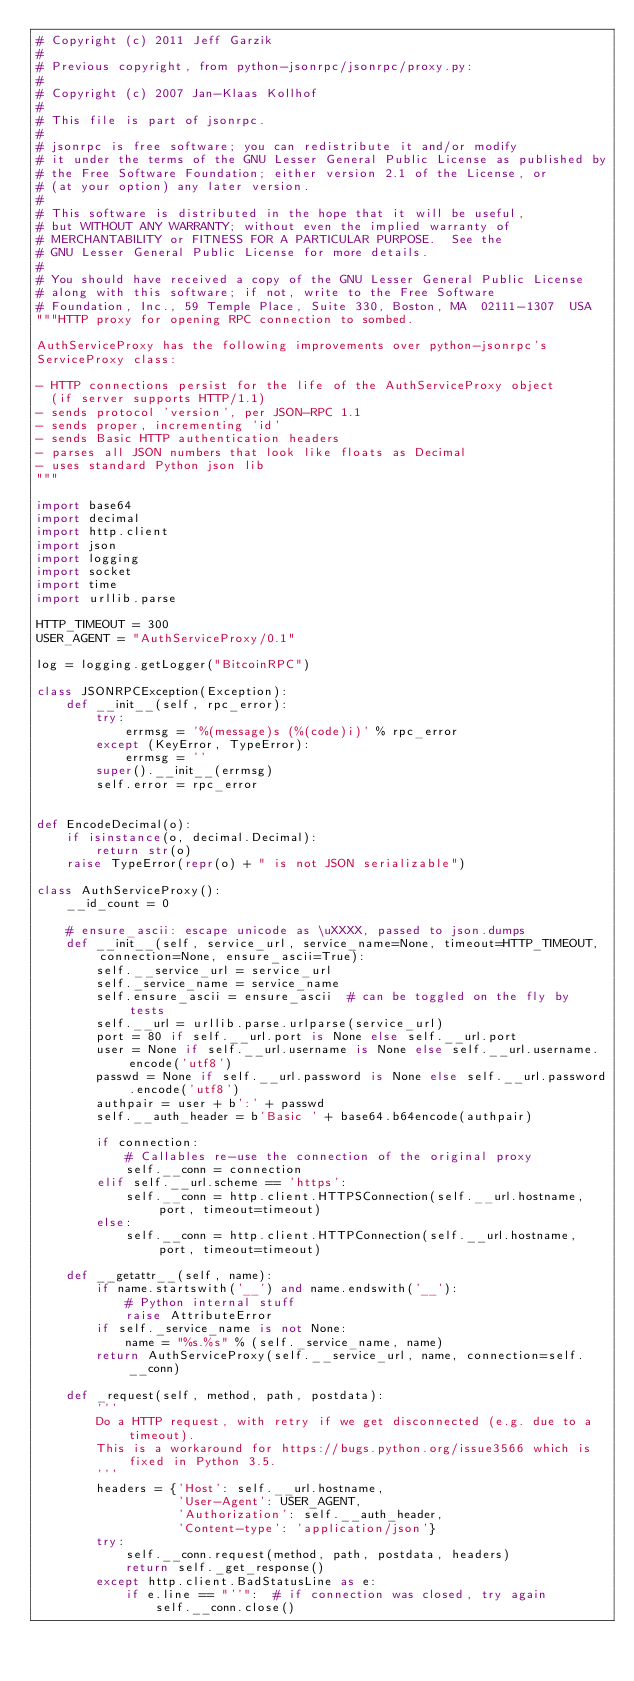<code> <loc_0><loc_0><loc_500><loc_500><_Python_># Copyright (c) 2011 Jeff Garzik
#
# Previous copyright, from python-jsonrpc/jsonrpc/proxy.py:
#
# Copyright (c) 2007 Jan-Klaas Kollhof
#
# This file is part of jsonrpc.
#
# jsonrpc is free software; you can redistribute it and/or modify
# it under the terms of the GNU Lesser General Public License as published by
# the Free Software Foundation; either version 2.1 of the License, or
# (at your option) any later version.
#
# This software is distributed in the hope that it will be useful,
# but WITHOUT ANY WARRANTY; without even the implied warranty of
# MERCHANTABILITY or FITNESS FOR A PARTICULAR PURPOSE.  See the
# GNU Lesser General Public License for more details.
#
# You should have received a copy of the GNU Lesser General Public License
# along with this software; if not, write to the Free Software
# Foundation, Inc., 59 Temple Place, Suite 330, Boston, MA  02111-1307  USA
"""HTTP proxy for opening RPC connection to sombed.

AuthServiceProxy has the following improvements over python-jsonrpc's
ServiceProxy class:

- HTTP connections persist for the life of the AuthServiceProxy object
  (if server supports HTTP/1.1)
- sends protocol 'version', per JSON-RPC 1.1
- sends proper, incrementing 'id'
- sends Basic HTTP authentication headers
- parses all JSON numbers that look like floats as Decimal
- uses standard Python json lib
"""

import base64
import decimal
import http.client
import json
import logging
import socket
import time
import urllib.parse

HTTP_TIMEOUT = 300
USER_AGENT = "AuthServiceProxy/0.1"

log = logging.getLogger("BitcoinRPC")

class JSONRPCException(Exception):
    def __init__(self, rpc_error):
        try:
            errmsg = '%(message)s (%(code)i)' % rpc_error
        except (KeyError, TypeError):
            errmsg = ''
        super().__init__(errmsg)
        self.error = rpc_error


def EncodeDecimal(o):
    if isinstance(o, decimal.Decimal):
        return str(o)
    raise TypeError(repr(o) + " is not JSON serializable")

class AuthServiceProxy():
    __id_count = 0

    # ensure_ascii: escape unicode as \uXXXX, passed to json.dumps
    def __init__(self, service_url, service_name=None, timeout=HTTP_TIMEOUT, connection=None, ensure_ascii=True):
        self.__service_url = service_url
        self._service_name = service_name
        self.ensure_ascii = ensure_ascii  # can be toggled on the fly by tests
        self.__url = urllib.parse.urlparse(service_url)
        port = 80 if self.__url.port is None else self.__url.port
        user = None if self.__url.username is None else self.__url.username.encode('utf8')
        passwd = None if self.__url.password is None else self.__url.password.encode('utf8')
        authpair = user + b':' + passwd
        self.__auth_header = b'Basic ' + base64.b64encode(authpair)

        if connection:
            # Callables re-use the connection of the original proxy
            self.__conn = connection
        elif self.__url.scheme == 'https':
            self.__conn = http.client.HTTPSConnection(self.__url.hostname, port, timeout=timeout)
        else:
            self.__conn = http.client.HTTPConnection(self.__url.hostname, port, timeout=timeout)

    def __getattr__(self, name):
        if name.startswith('__') and name.endswith('__'):
            # Python internal stuff
            raise AttributeError
        if self._service_name is not None:
            name = "%s.%s" % (self._service_name, name)
        return AuthServiceProxy(self.__service_url, name, connection=self.__conn)

    def _request(self, method, path, postdata):
        '''
        Do a HTTP request, with retry if we get disconnected (e.g. due to a timeout).
        This is a workaround for https://bugs.python.org/issue3566 which is fixed in Python 3.5.
        '''
        headers = {'Host': self.__url.hostname,
                   'User-Agent': USER_AGENT,
                   'Authorization': self.__auth_header,
                   'Content-type': 'application/json'}
        try:
            self.__conn.request(method, path, postdata, headers)
            return self._get_response()
        except http.client.BadStatusLine as e:
            if e.line == "''":  # if connection was closed, try again
                self.__conn.close()</code> 